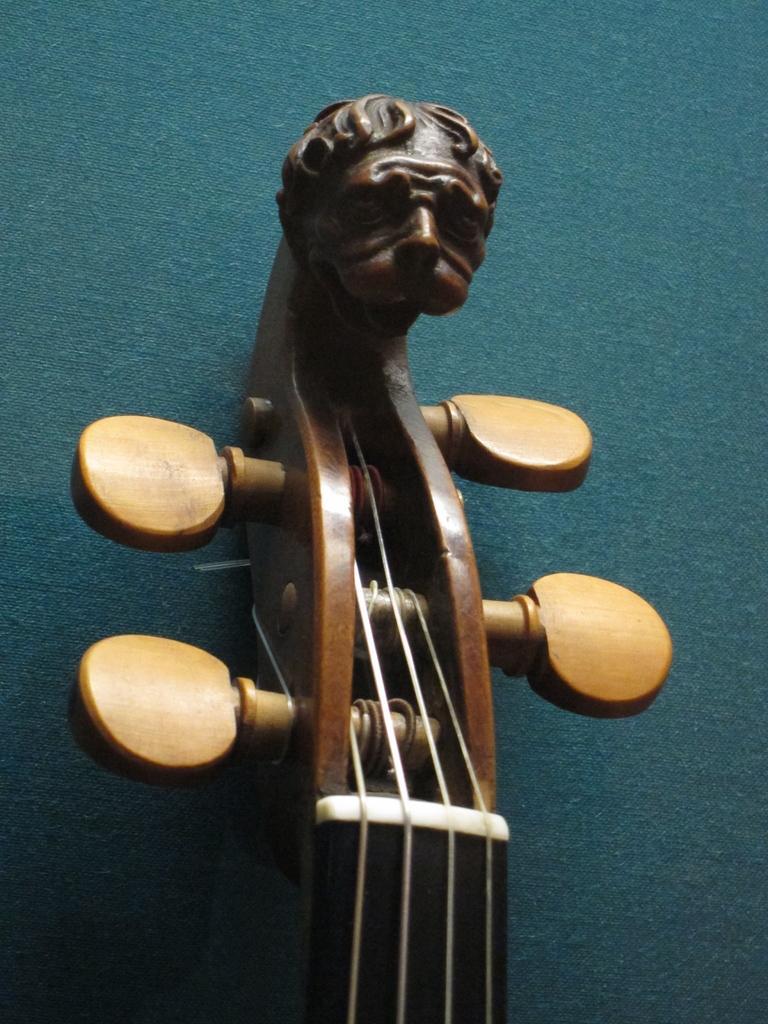In one or two sentences, can you explain what this image depicts? This image consists of some musical instrument. The background is in blue color, and this musical instrument is in brown color. 